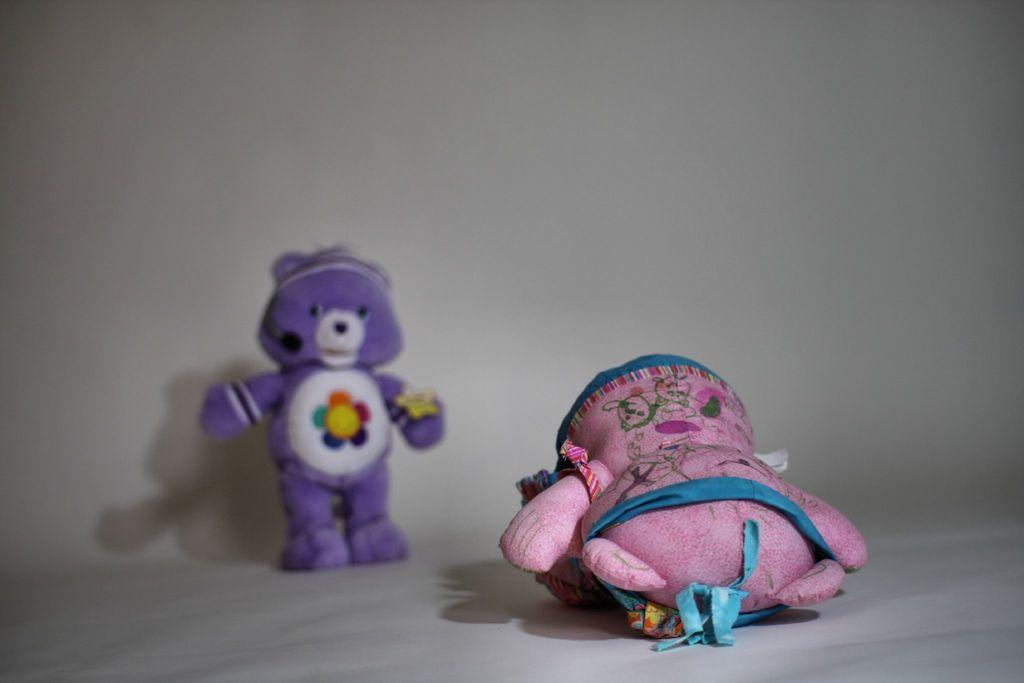How many teddy bears are present in the image? There are two teddy bears in the image. What can be observed about the background of the image? The background of the image is white. What type of digestion system does the owl have in the image? There is no owl present in the image, so it is not possible to determine its digestion system. 